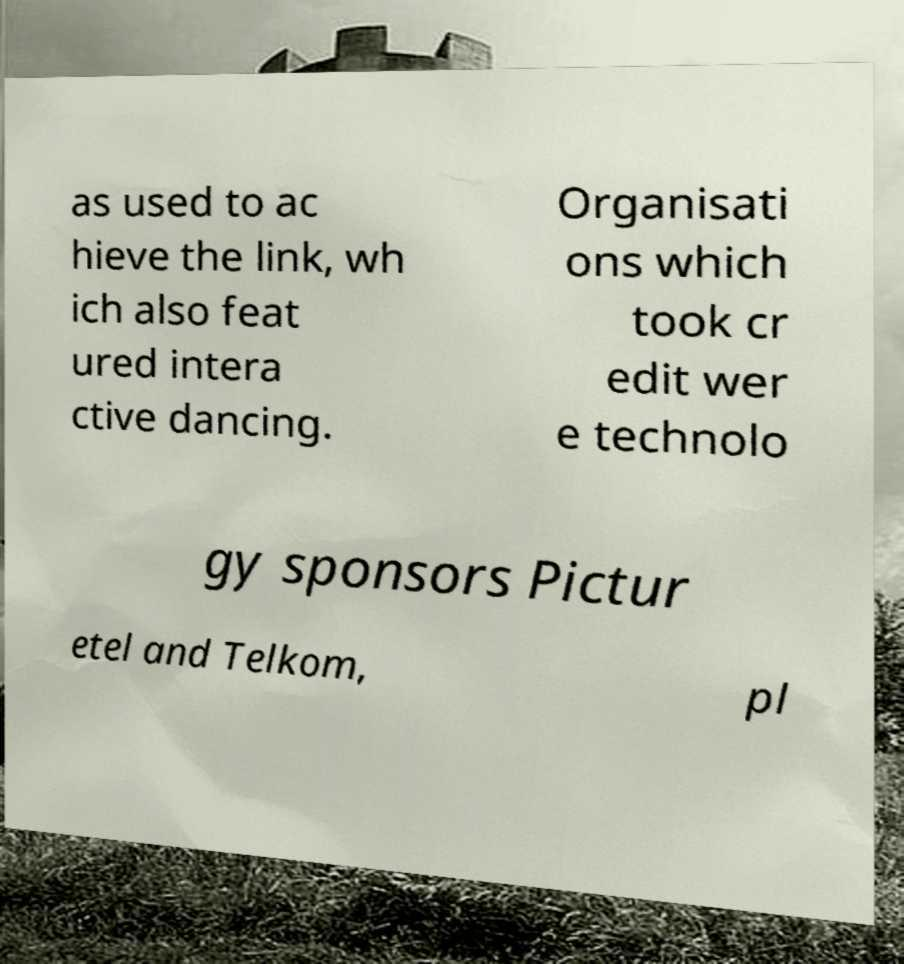What messages or text are displayed in this image? I need them in a readable, typed format. as used to ac hieve the link, wh ich also feat ured intera ctive dancing. Organisati ons which took cr edit wer e technolo gy sponsors Pictur etel and Telkom, pl 